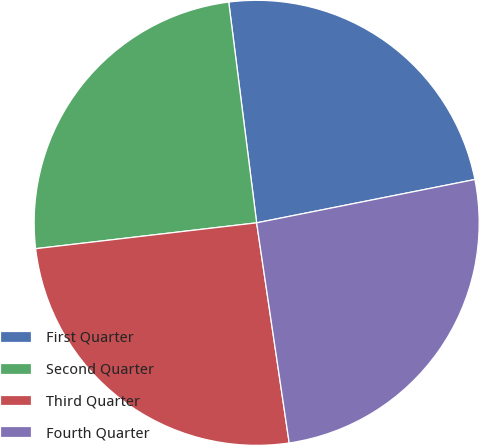Convert chart to OTSL. <chart><loc_0><loc_0><loc_500><loc_500><pie_chart><fcel>First Quarter<fcel>Second Quarter<fcel>Third Quarter<fcel>Fourth Quarter<nl><fcel>23.88%<fcel>24.85%<fcel>25.48%<fcel>25.78%<nl></chart> 